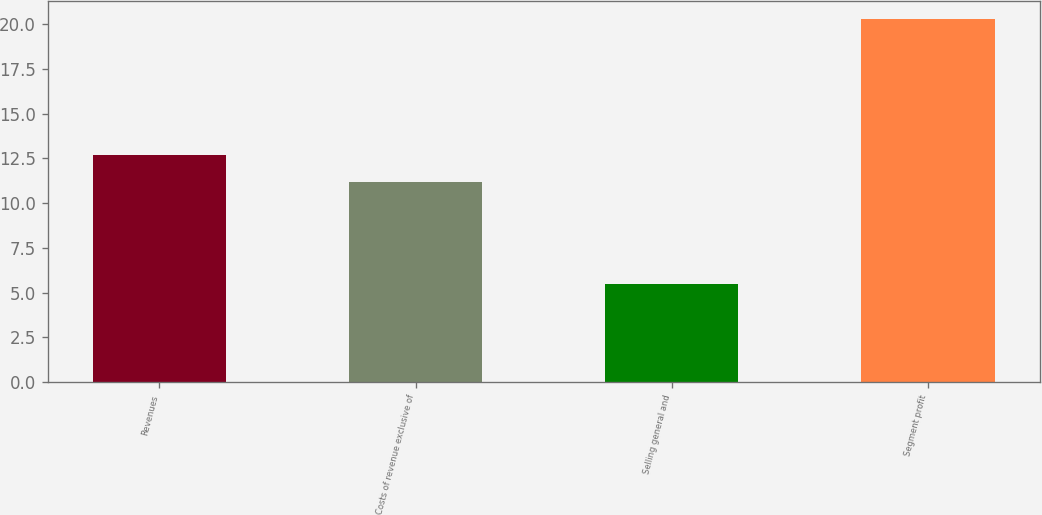Convert chart to OTSL. <chart><loc_0><loc_0><loc_500><loc_500><bar_chart><fcel>Revenues<fcel>Costs of revenue exclusive of<fcel>Selling general and<fcel>Segment profit<nl><fcel>12.68<fcel>11.2<fcel>5.5<fcel>20.3<nl></chart> 